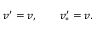Convert formula to latex. <formula><loc_0><loc_0><loc_500><loc_500>v ^ { \prime } = v , \quad v _ { \ast } ^ { \prime } = v .</formula> 